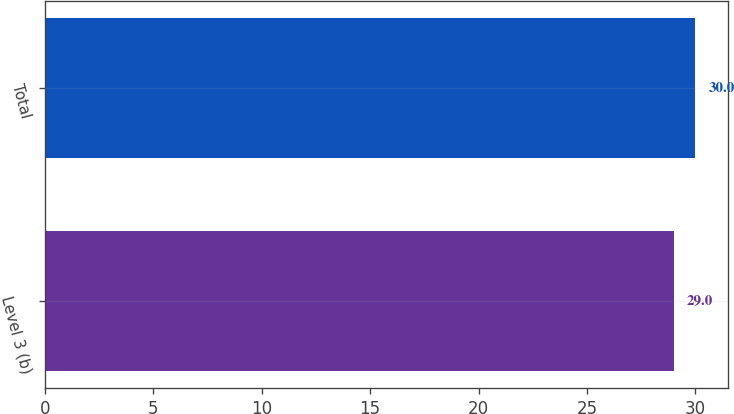Convert chart to OTSL. <chart><loc_0><loc_0><loc_500><loc_500><bar_chart><fcel>Level 3 (b)<fcel>Total<nl><fcel>29<fcel>30<nl></chart> 